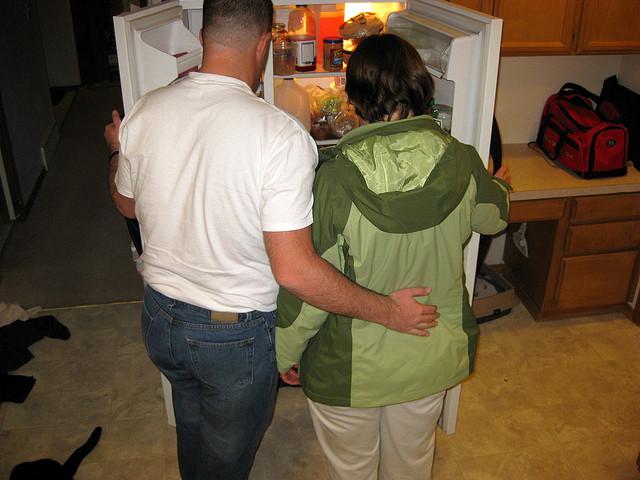What did these people choose to have for dinner?
Keep it brief. Food. Is this a couple?
Keep it brief. Yes. What is the girl putting in the fridge?
Quick response, please. Nothing. Are these people looking at the camera?
Write a very short answer. No. 